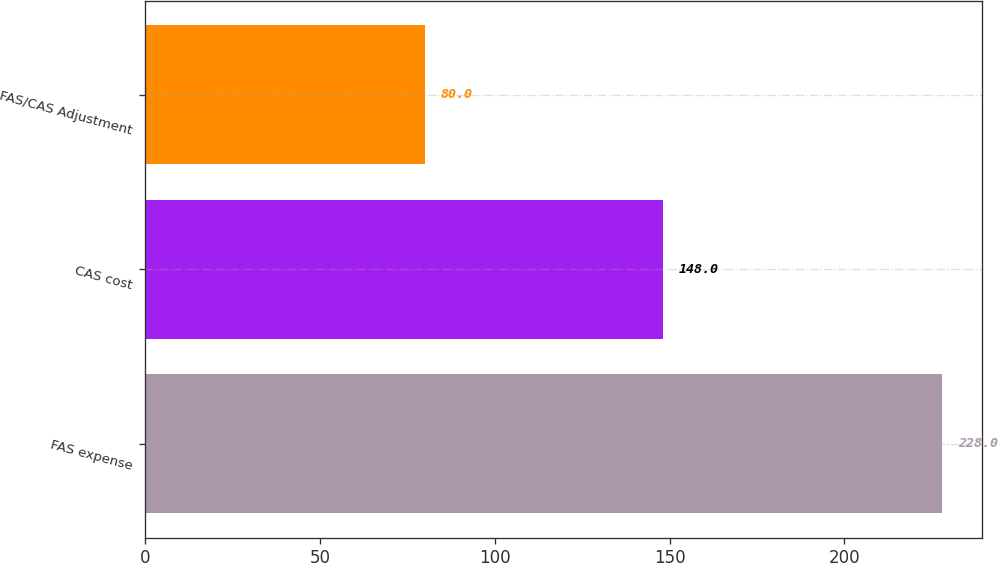Convert chart to OTSL. <chart><loc_0><loc_0><loc_500><loc_500><bar_chart><fcel>FAS expense<fcel>CAS cost<fcel>FAS/CAS Adjustment<nl><fcel>228<fcel>148<fcel>80<nl></chart> 